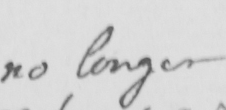What does this handwritten line say? no longer 